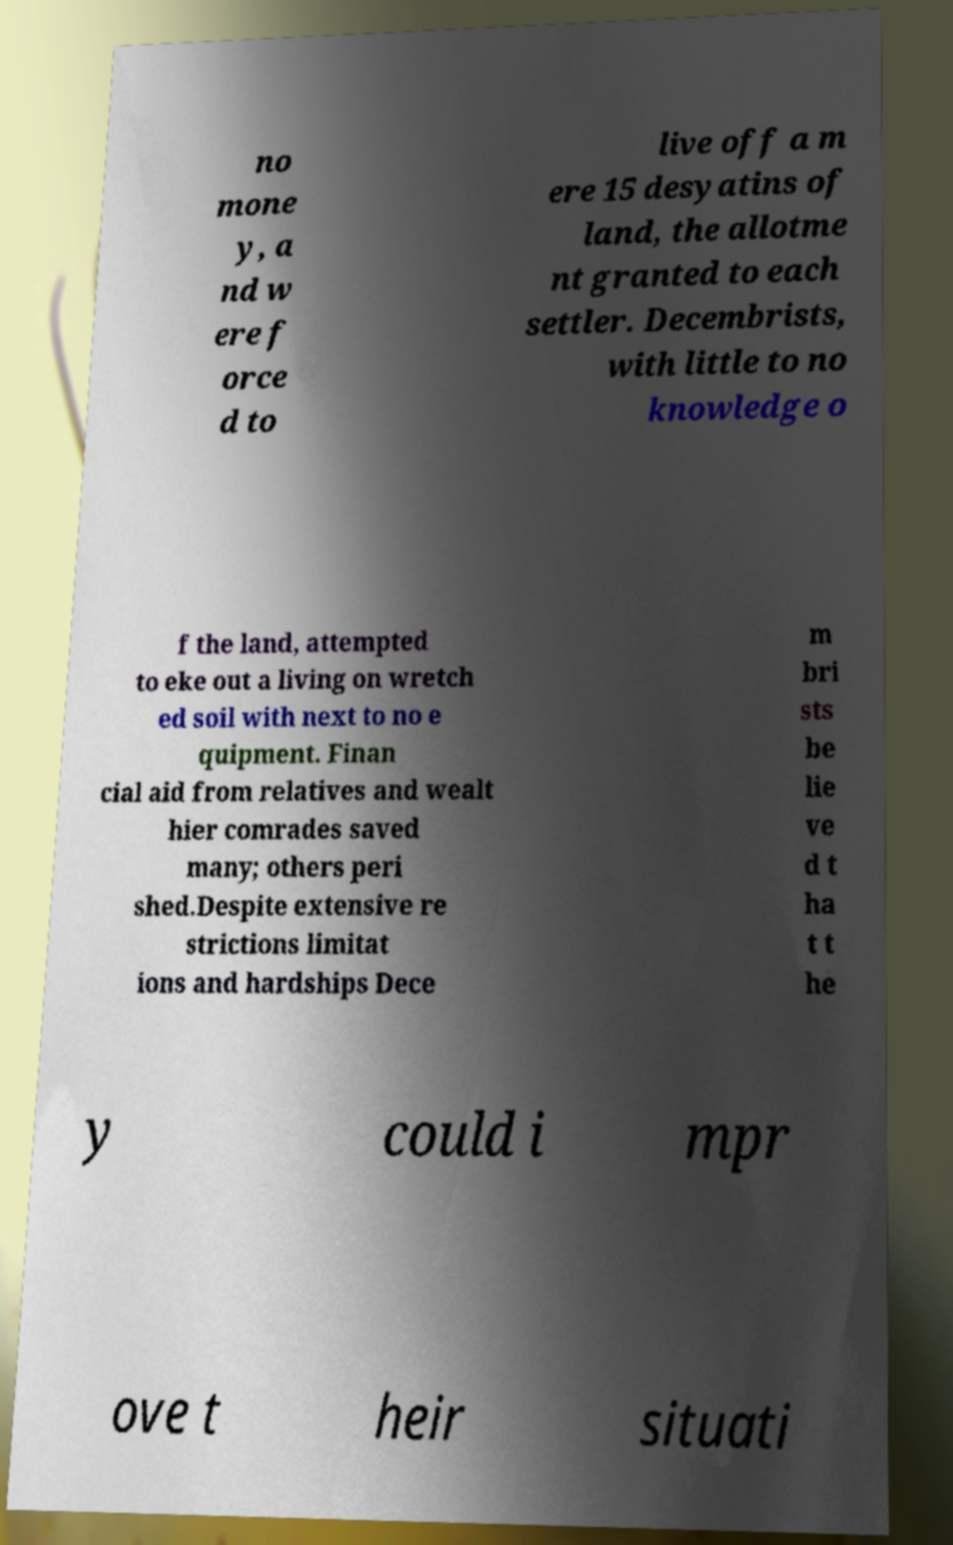There's text embedded in this image that I need extracted. Can you transcribe it verbatim? no mone y, a nd w ere f orce d to live off a m ere 15 desyatins of land, the allotme nt granted to each settler. Decembrists, with little to no knowledge o f the land, attempted to eke out a living on wretch ed soil with next to no e quipment. Finan cial aid from relatives and wealt hier comrades saved many; others peri shed.Despite extensive re strictions limitat ions and hardships Dece m bri sts be lie ve d t ha t t he y could i mpr ove t heir situati 